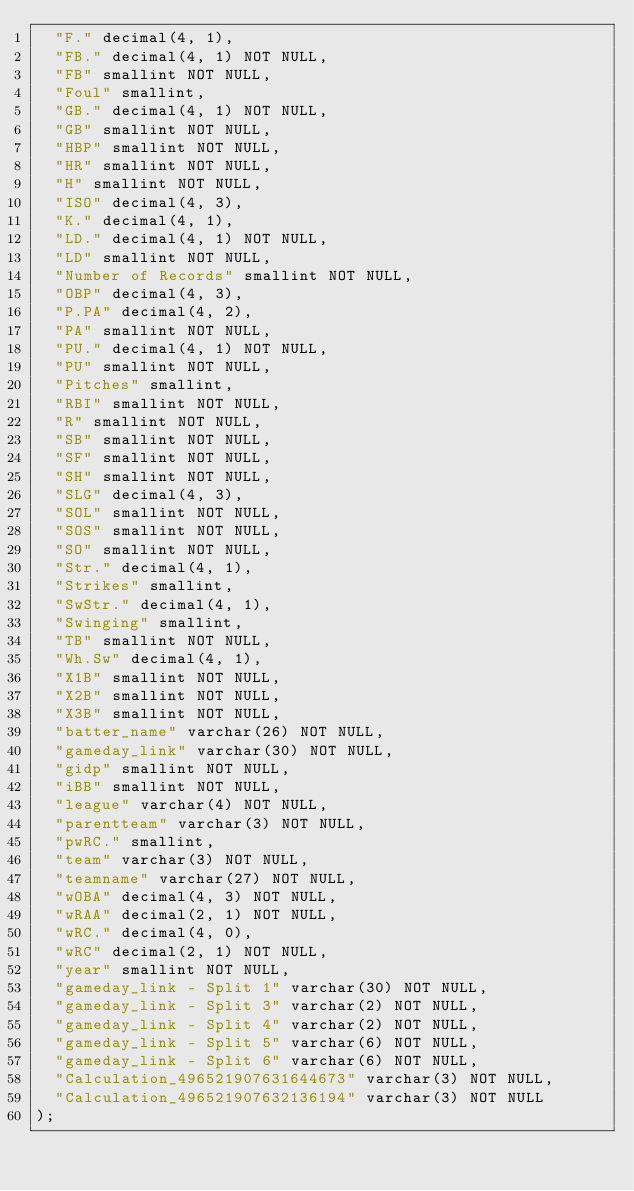<code> <loc_0><loc_0><loc_500><loc_500><_SQL_>  "F." decimal(4, 1),
  "FB." decimal(4, 1) NOT NULL,
  "FB" smallint NOT NULL,
  "Foul" smallint,
  "GB." decimal(4, 1) NOT NULL,
  "GB" smallint NOT NULL,
  "HBP" smallint NOT NULL,
  "HR" smallint NOT NULL,
  "H" smallint NOT NULL,
  "ISO" decimal(4, 3),
  "K." decimal(4, 1),
  "LD." decimal(4, 1) NOT NULL,
  "LD" smallint NOT NULL,
  "Number of Records" smallint NOT NULL,
  "OBP" decimal(4, 3),
  "P.PA" decimal(4, 2),
  "PA" smallint NOT NULL,
  "PU." decimal(4, 1) NOT NULL,
  "PU" smallint NOT NULL,
  "Pitches" smallint,
  "RBI" smallint NOT NULL,
  "R" smallint NOT NULL,
  "SB" smallint NOT NULL,
  "SF" smallint NOT NULL,
  "SH" smallint NOT NULL,
  "SLG" decimal(4, 3),
  "SOL" smallint NOT NULL,
  "SOS" smallint NOT NULL,
  "SO" smallint NOT NULL,
  "Str." decimal(4, 1),
  "Strikes" smallint,
  "SwStr." decimal(4, 1),
  "Swinging" smallint,
  "TB" smallint NOT NULL,
  "Wh.Sw" decimal(4, 1),
  "X1B" smallint NOT NULL,
  "X2B" smallint NOT NULL,
  "X3B" smallint NOT NULL,
  "batter_name" varchar(26) NOT NULL,
  "gameday_link" varchar(30) NOT NULL,
  "gidp" smallint NOT NULL,
  "iBB" smallint NOT NULL,
  "league" varchar(4) NOT NULL,
  "parentteam" varchar(3) NOT NULL,
  "pwRC." smallint,
  "team" varchar(3) NOT NULL,
  "teamname" varchar(27) NOT NULL,
  "wOBA" decimal(4, 3) NOT NULL,
  "wRAA" decimal(2, 1) NOT NULL,
  "wRC." decimal(4, 0),
  "wRC" decimal(2, 1) NOT NULL,
  "year" smallint NOT NULL,
  "gameday_link - Split 1" varchar(30) NOT NULL,
  "gameday_link - Split 3" varchar(2) NOT NULL,
  "gameday_link - Split 4" varchar(2) NOT NULL,
  "gameday_link - Split 5" varchar(6) NOT NULL,
  "gameday_link - Split 6" varchar(6) NOT NULL,
  "Calculation_496521907631644673" varchar(3) NOT NULL,
  "Calculation_496521907632136194" varchar(3) NOT NULL
);
</code> 